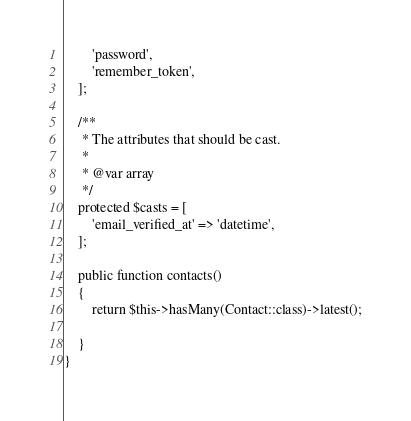Convert code to text. <code><loc_0><loc_0><loc_500><loc_500><_PHP_>        'password',
        'remember_token',
    ];

    /**
     * The attributes that should be cast.
     *
     * @var array
     */
    protected $casts = [
        'email_verified_at' => 'datetime',
    ];

    public function contacts() 
    {
        return $this->hasMany(Contact::class)->latest();
        
    }
}
</code> 